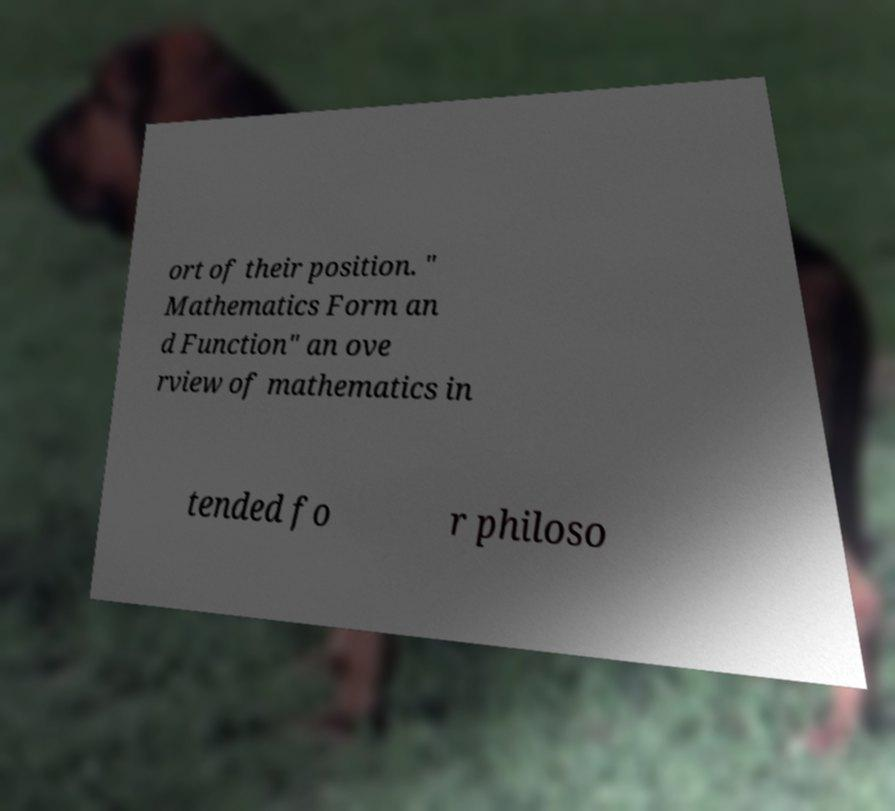Please read and relay the text visible in this image. What does it say? ort of their position. " Mathematics Form an d Function" an ove rview of mathematics in tended fo r philoso 